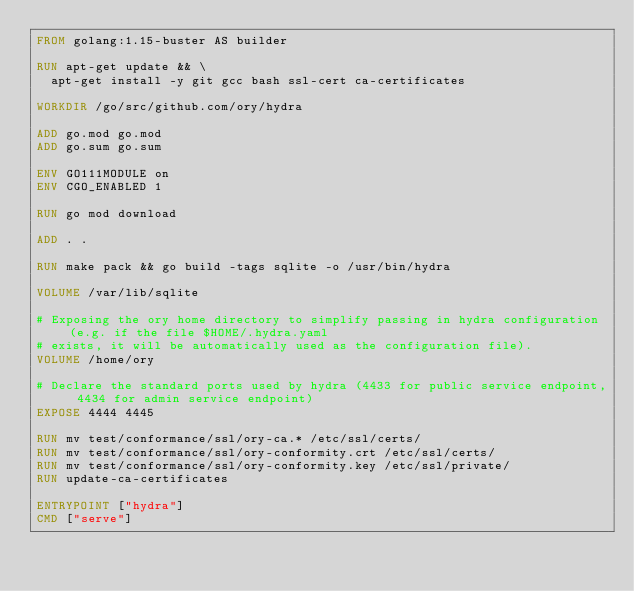Convert code to text. <code><loc_0><loc_0><loc_500><loc_500><_Dockerfile_>FROM golang:1.15-buster AS builder

RUN apt-get update && \
  apt-get install -y git gcc bash ssl-cert ca-certificates

WORKDIR /go/src/github.com/ory/hydra

ADD go.mod go.mod
ADD go.sum go.sum

ENV GO111MODULE on
ENV CGO_ENABLED 1

RUN go mod download

ADD . .

RUN make pack && go build -tags sqlite -o /usr/bin/hydra

VOLUME /var/lib/sqlite

# Exposing the ory home directory to simplify passing in hydra configuration (e.g. if the file $HOME/.hydra.yaml
# exists, it will be automatically used as the configuration file).
VOLUME /home/ory

# Declare the standard ports used by hydra (4433 for public service endpoint, 4434 for admin service endpoint)
EXPOSE 4444 4445

RUN mv test/conformance/ssl/ory-ca.* /etc/ssl/certs/
RUN mv test/conformance/ssl/ory-conformity.crt /etc/ssl/certs/
RUN mv test/conformance/ssl/ory-conformity.key /etc/ssl/private/
RUN update-ca-certificates

ENTRYPOINT ["hydra"]
CMD ["serve"]
</code> 